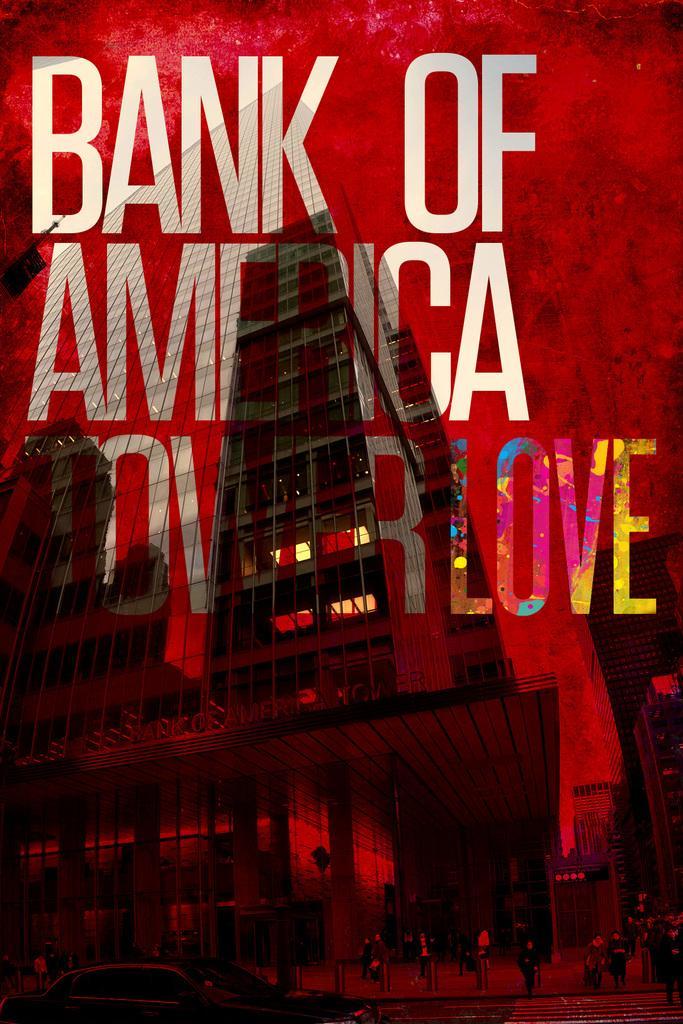Describe this image in one or two sentences. In this image there is a poster with some text and the image of the building. 